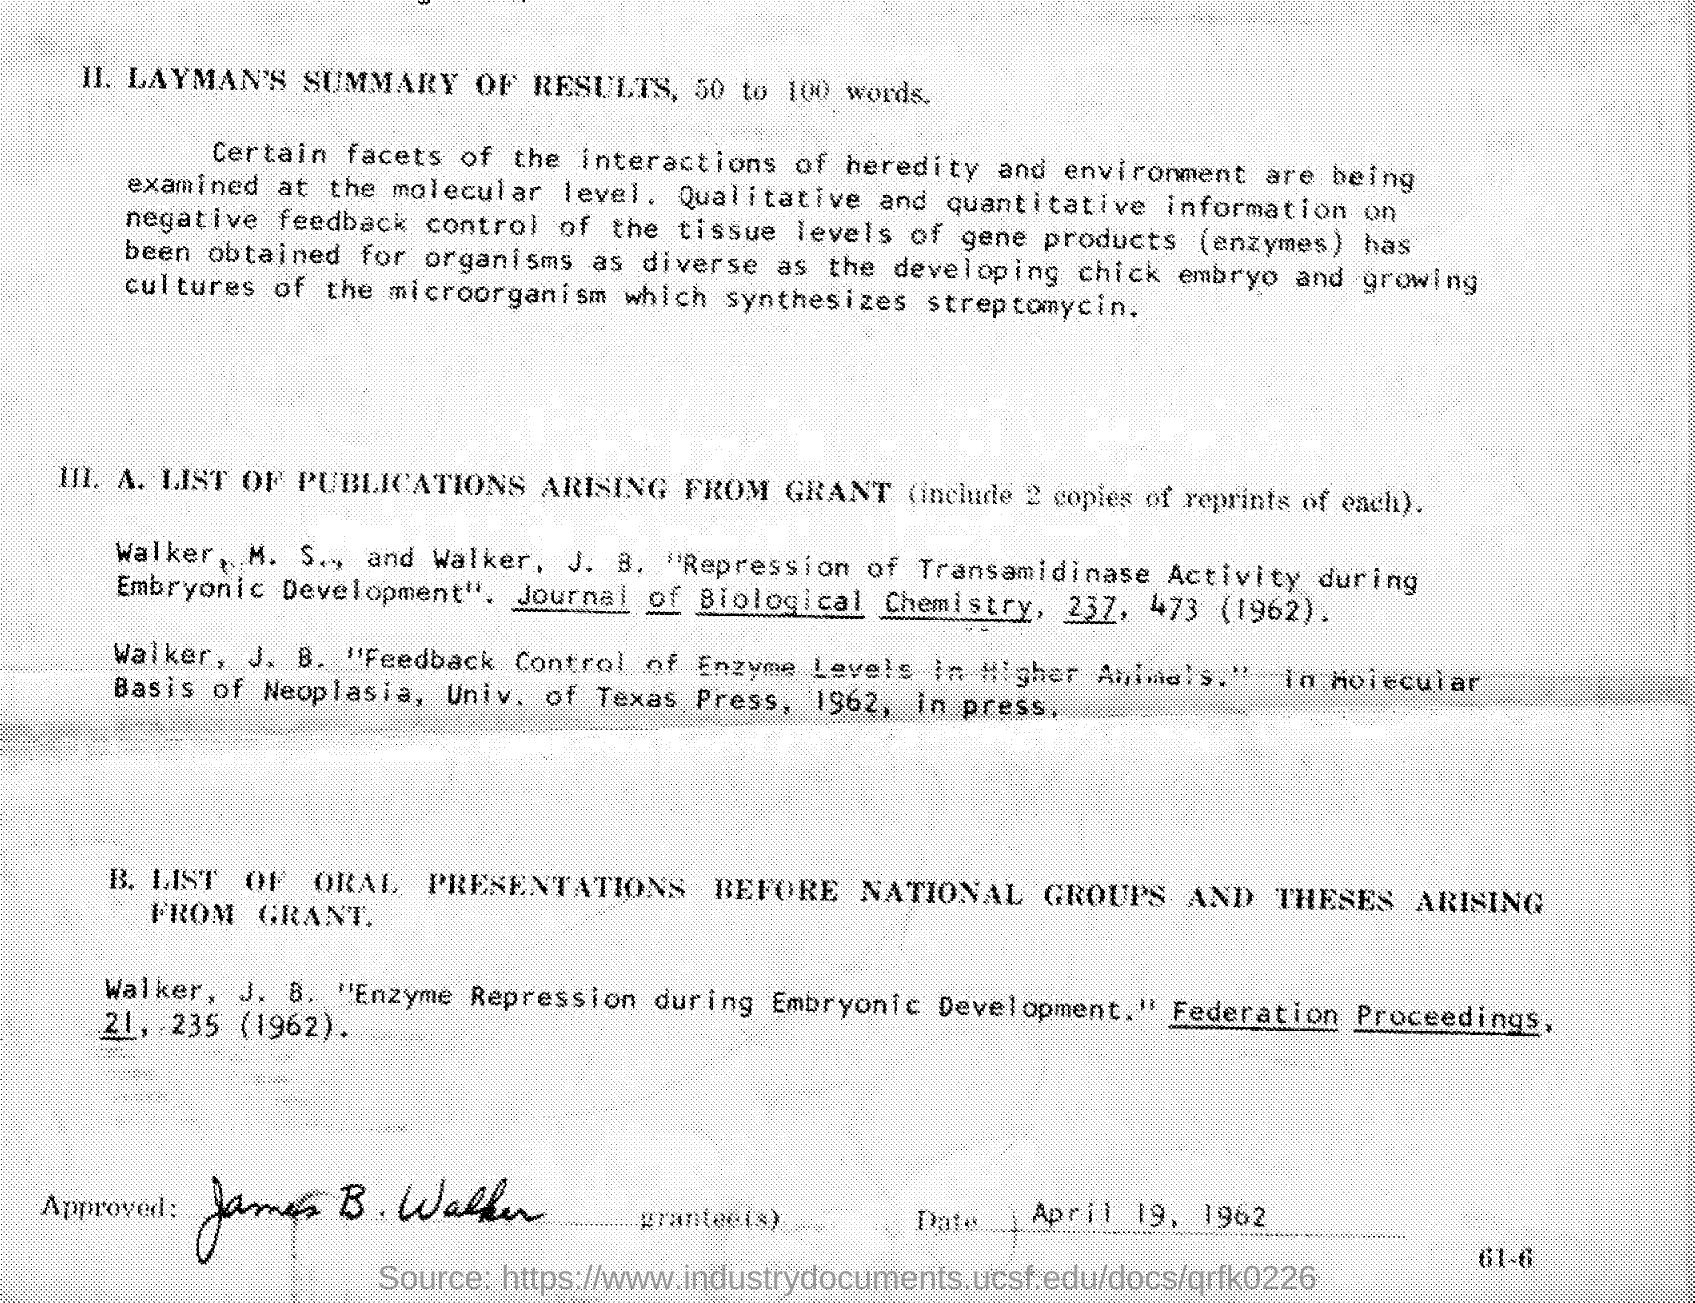Mention a couple of crucial points in this snapshot. The document was approved by James B. Walker. The date at the bottom of the document is April 19, 1962. 